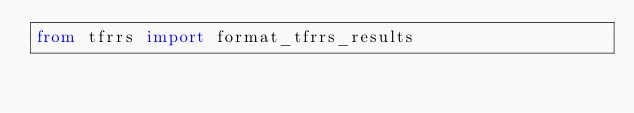Convert code to text. <code><loc_0><loc_0><loc_500><loc_500><_Python_>from tfrrs import format_tfrrs_results
</code> 